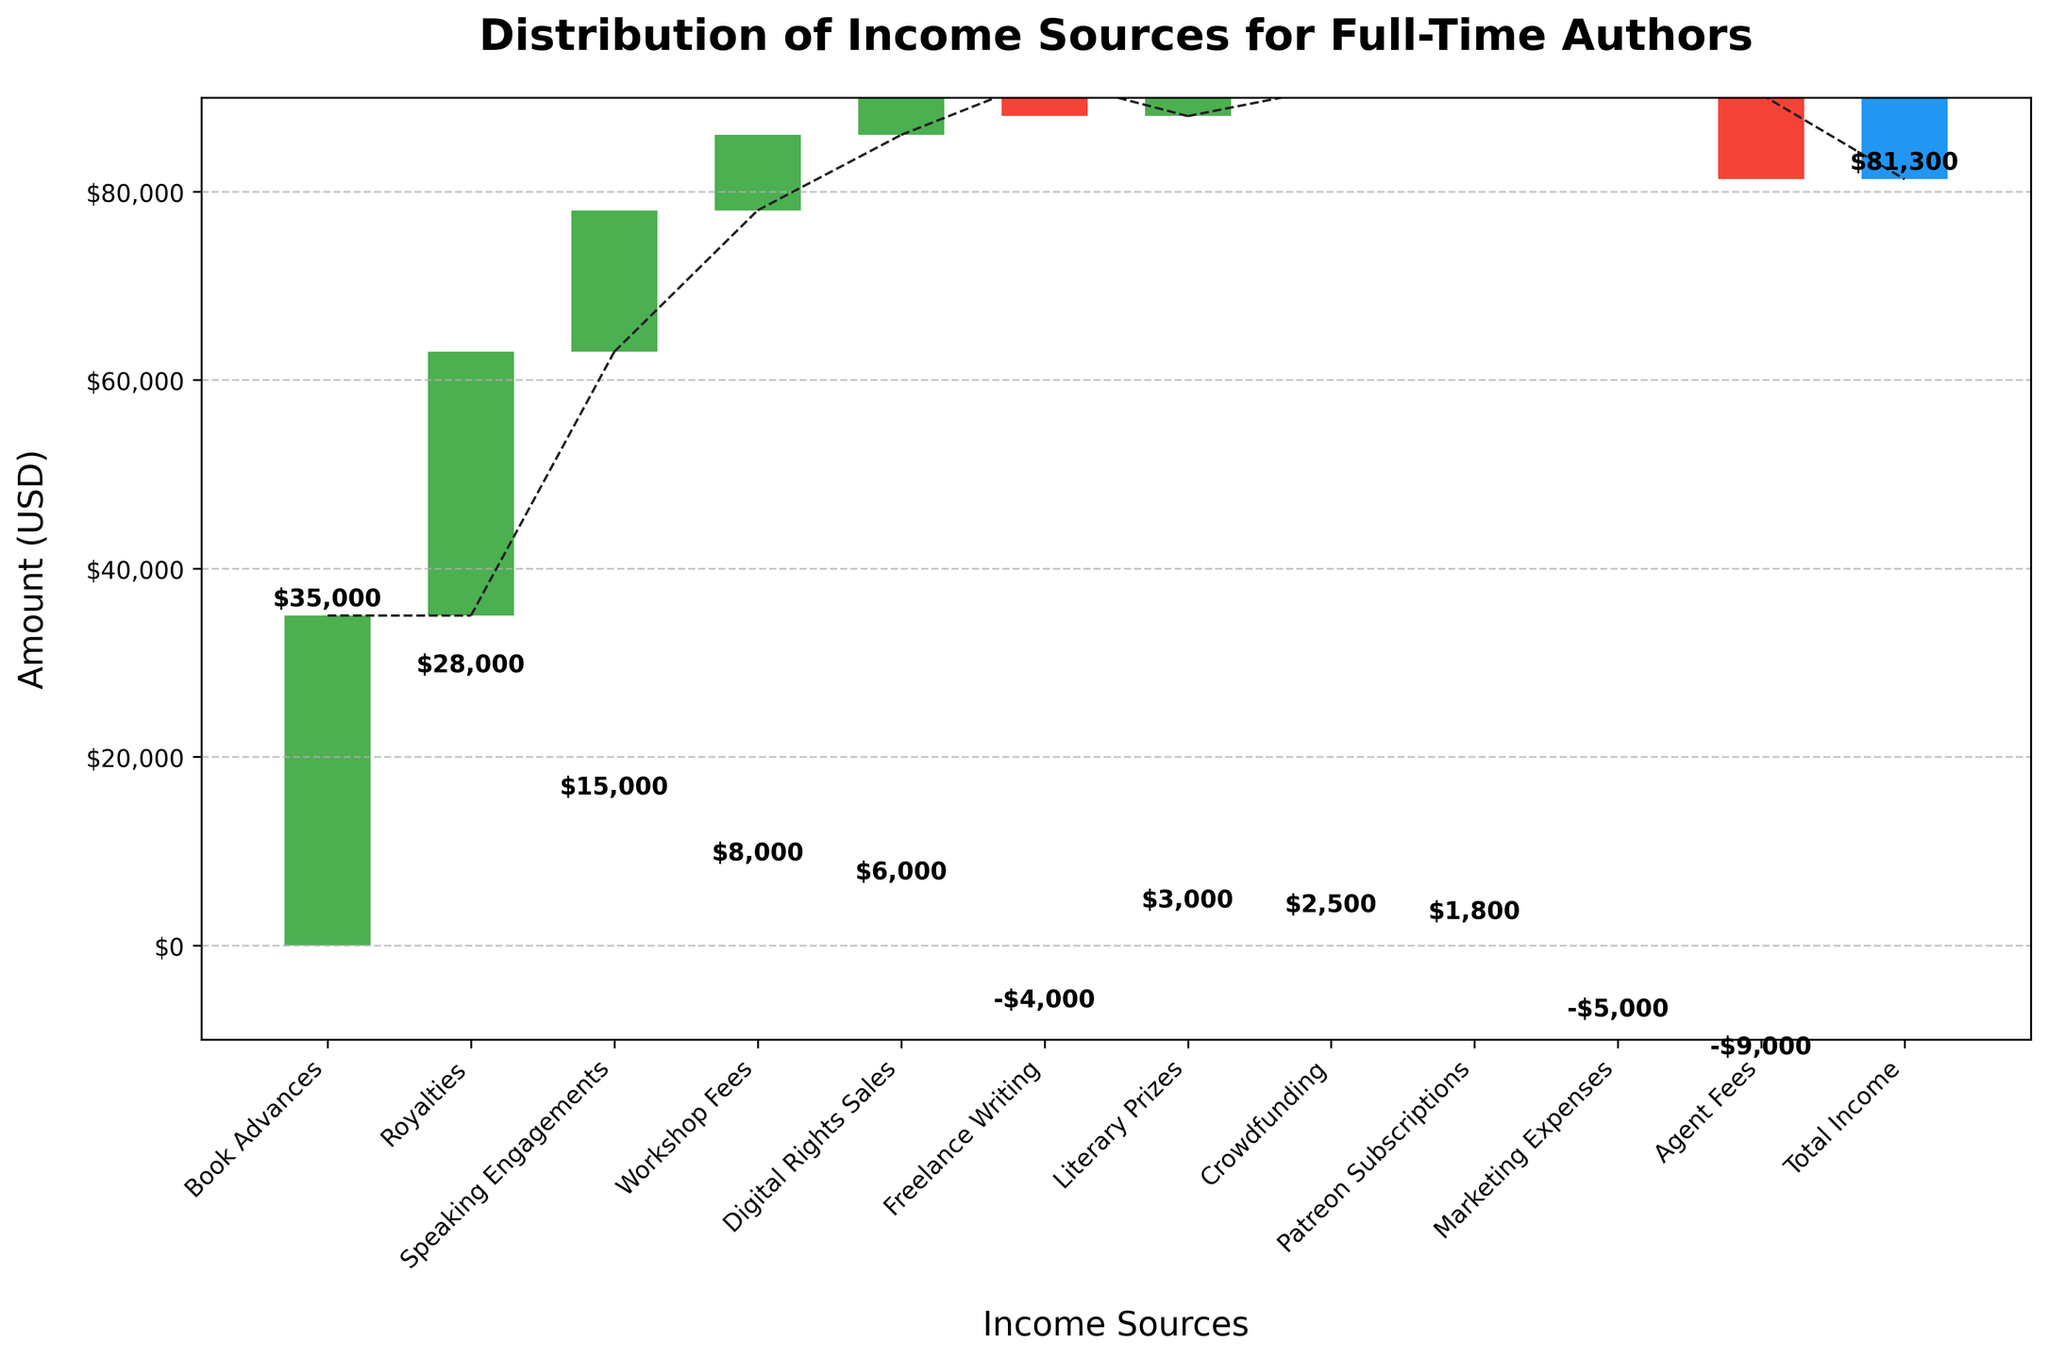What is the title of the chart? The title of the chart is usually placed at the top of the figure. In this chart, the title is "Distribution of Income Sources for Full-Time Authors".
Answer: Distribution of Income Sources for Full-Time Authors Which income source has the highest value? Look for the tallest bar in the chart. The tallest bar represents "Book Advances" with a value of 35,000 USD.
Answer: Book Advances What is the net effect of "Marketing Expenses" and "Agent Fees"? Add the values of "Marketing Expenses" and "Agent Fees": -5,000 + (-9,000) = -14,000 USD.
Answer: -14,000 USD Which income sources contribute negatively to the total income? Identify bars with negative values, shown in red color. The negative income sources are "Freelance Writing", "Marketing Expenses", and "Agent Fees".
Answer: Freelance Writing, Marketing Expenses, Agent Fees What is the total income value for full-time authors after considering all sources? The total income is the final value shown in the chart, which is depicted by the last bar labeled "Total Income". The value is 81,300 USD.
Answer: 81,300 USD How does "Royalties" compare to "Digital Rights Sales"? Compare the height of the bars for "Royalties" and "Digital Rights Sales". "Royalties" is higher with 28,000 USD, while "Digital Rights Sales" has 6,000 USD.
Answer: Higher Which category is the least profitable? Identify the smallest negative bar, as it represents the least profitable source. "Agent Fees" with -9,000 USD is the least profitable.
Answer: Agent Fees By adding "Crowdfunding" and "Patreon Subscriptions", what is the combined contribution of these sources? Sum the values: 2,500 (Crowdfunding) + 1,800 (Patreon Subscriptions) = 4,300 USD.
Answer: 4,300 USD How many categories contribute positively to the total income? Count the number of bars with positive values (green color). These are: "Book Advances", "Royalties", "Speaking Engagements", "Workshop Fees", "Digital Rights Sales", "Literary Prizes", "Crowdfunding", and "Patreon Subscriptions". There are 8 positive contributors.
Answer: 8 